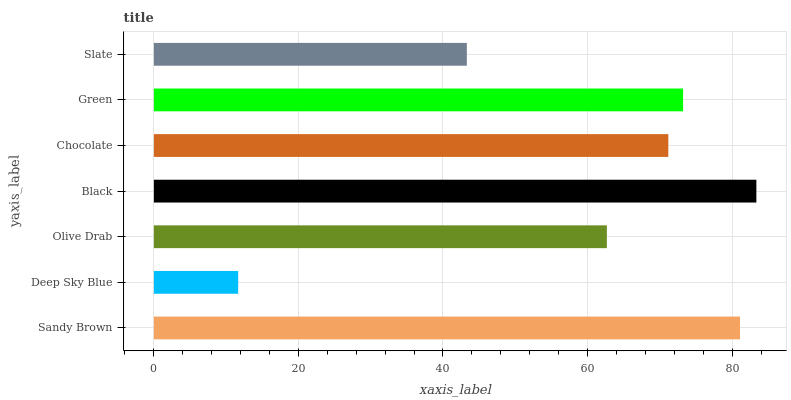Is Deep Sky Blue the minimum?
Answer yes or no. Yes. Is Black the maximum?
Answer yes or no. Yes. Is Olive Drab the minimum?
Answer yes or no. No. Is Olive Drab the maximum?
Answer yes or no. No. Is Olive Drab greater than Deep Sky Blue?
Answer yes or no. Yes. Is Deep Sky Blue less than Olive Drab?
Answer yes or no. Yes. Is Deep Sky Blue greater than Olive Drab?
Answer yes or no. No. Is Olive Drab less than Deep Sky Blue?
Answer yes or no. No. Is Chocolate the high median?
Answer yes or no. Yes. Is Chocolate the low median?
Answer yes or no. Yes. Is Slate the high median?
Answer yes or no. No. Is Black the low median?
Answer yes or no. No. 